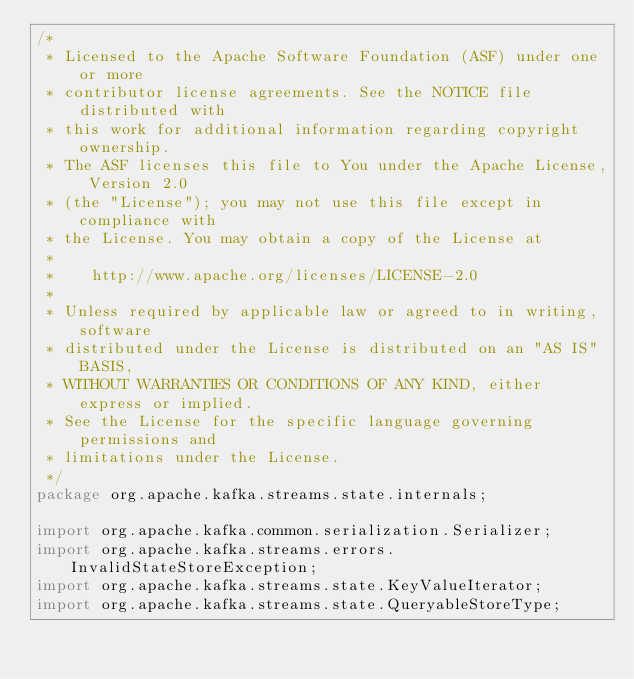<code> <loc_0><loc_0><loc_500><loc_500><_Java_>/*
 * Licensed to the Apache Software Foundation (ASF) under one or more
 * contributor license agreements. See the NOTICE file distributed with
 * this work for additional information regarding copyright ownership.
 * The ASF licenses this file to You under the Apache License, Version 2.0
 * (the "License"); you may not use this file except in compliance with
 * the License. You may obtain a copy of the License at
 *
 *    http://www.apache.org/licenses/LICENSE-2.0
 *
 * Unless required by applicable law or agreed to in writing, software
 * distributed under the License is distributed on an "AS IS" BASIS,
 * WITHOUT WARRANTIES OR CONDITIONS OF ANY KIND, either express or implied.
 * See the License for the specific language governing permissions and
 * limitations under the License.
 */
package org.apache.kafka.streams.state.internals;

import org.apache.kafka.common.serialization.Serializer;
import org.apache.kafka.streams.errors.InvalidStateStoreException;
import org.apache.kafka.streams.state.KeyValueIterator;
import org.apache.kafka.streams.state.QueryableStoreType;</code> 